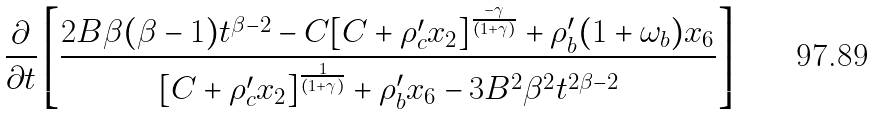<formula> <loc_0><loc_0><loc_500><loc_500>\frac { \partial } { \partial { t } } \left [ \frac { 2 B \beta ( \beta - 1 ) t ^ { \beta - 2 } - C [ C + \rho _ { c } ^ { \prime } x _ { 2 } ] ^ { \frac { - \gamma } { ( 1 + \gamma ) } } + \rho _ { b } ^ { \prime } ( 1 + \omega _ { b } ) x _ { 6 } } { [ C + \rho _ { c } ^ { \prime } x _ { 2 } ] ^ { \frac { 1 } { ( 1 + \gamma ) } } + \rho _ { b } ^ { \prime } x _ { 6 } - 3 B ^ { 2 } \beta ^ { 2 } t ^ { 2 \beta - 2 } } \right ]</formula> 